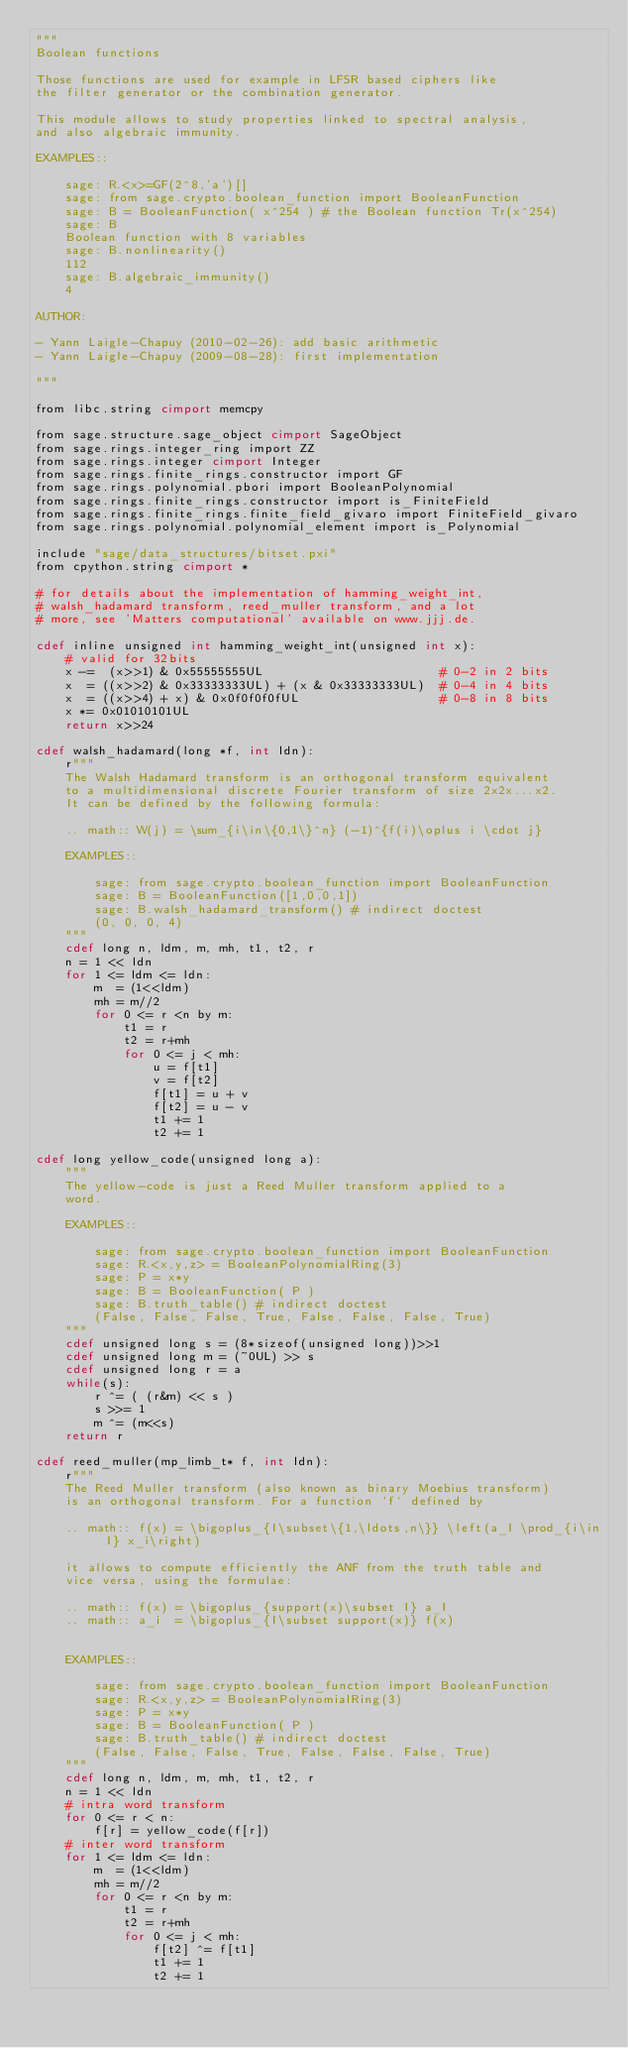<code> <loc_0><loc_0><loc_500><loc_500><_Cython_>"""
Boolean functions

Those functions are used for example in LFSR based ciphers like
the filter generator or the combination generator.

This module allows to study properties linked to spectral analysis,
and also algebraic immunity.

EXAMPLES::

    sage: R.<x>=GF(2^8,'a')[]
    sage: from sage.crypto.boolean_function import BooleanFunction
    sage: B = BooleanFunction( x^254 ) # the Boolean function Tr(x^254)
    sage: B
    Boolean function with 8 variables
    sage: B.nonlinearity()
    112
    sage: B.algebraic_immunity()
    4

AUTHOR:

- Yann Laigle-Chapuy (2010-02-26): add basic arithmetic
- Yann Laigle-Chapuy (2009-08-28): first implementation

"""

from libc.string cimport memcpy

from sage.structure.sage_object cimport SageObject
from sage.rings.integer_ring import ZZ
from sage.rings.integer cimport Integer
from sage.rings.finite_rings.constructor import GF
from sage.rings.polynomial.pbori import BooleanPolynomial
from sage.rings.finite_rings.constructor import is_FiniteField
from sage.rings.finite_rings.finite_field_givaro import FiniteField_givaro
from sage.rings.polynomial.polynomial_element import is_Polynomial

include "sage/data_structures/bitset.pxi"
from cpython.string cimport *

# for details about the implementation of hamming_weight_int,
# walsh_hadamard transform, reed_muller transform, and a lot
# more, see 'Matters computational' available on www.jjj.de.

cdef inline unsigned int hamming_weight_int(unsigned int x):
    # valid for 32bits
    x -=  (x>>1) & 0x55555555UL                        # 0-2 in 2 bits
    x  = ((x>>2) & 0x33333333UL) + (x & 0x33333333UL)  # 0-4 in 4 bits
    x  = ((x>>4) + x) & 0x0f0f0f0fUL                   # 0-8 in 8 bits
    x *= 0x01010101UL
    return x>>24

cdef walsh_hadamard(long *f, int ldn):
    r"""
    The Walsh Hadamard transform is an orthogonal transform equivalent
    to a multidimensional discrete Fourier transform of size 2x2x...x2.
    It can be defined by the following formula:

    .. math:: W(j) = \sum_{i\in\{0,1\}^n} (-1)^{f(i)\oplus i \cdot j}

    EXAMPLES::

        sage: from sage.crypto.boolean_function import BooleanFunction
        sage: B = BooleanFunction([1,0,0,1])
        sage: B.walsh_hadamard_transform() # indirect doctest
        (0, 0, 0, 4)
    """
    cdef long n, ldm, m, mh, t1, t2, r
    n = 1 << ldn
    for 1 <= ldm <= ldn:
        m  = (1<<ldm)
        mh = m//2
        for 0 <= r <n by m:
            t1 = r
            t2 = r+mh
            for 0 <= j < mh:
                u = f[t1]
                v = f[t2]
                f[t1] = u + v
                f[t2] = u - v
                t1 += 1
                t2 += 1

cdef long yellow_code(unsigned long a):
    """
    The yellow-code is just a Reed Muller transform applied to a
    word.

    EXAMPLES::

        sage: from sage.crypto.boolean_function import BooleanFunction
        sage: R.<x,y,z> = BooleanPolynomialRing(3)
        sage: P = x*y
        sage: B = BooleanFunction( P )
        sage: B.truth_table() # indirect doctest
        (False, False, False, True, False, False, False, True)
    """
    cdef unsigned long s = (8*sizeof(unsigned long))>>1
    cdef unsigned long m = (~0UL) >> s
    cdef unsigned long r = a
    while(s):
        r ^= ( (r&m) << s )
        s >>= 1
        m ^= (m<<s)
    return r

cdef reed_muller(mp_limb_t* f, int ldn):
    r"""
    The Reed Muller transform (also known as binary Moebius transform)
    is an orthogonal transform. For a function `f` defined by

    .. math:: f(x) = \bigoplus_{I\subset\{1,\ldots,n\}} \left(a_I \prod_{i\in I} x_i\right)

    it allows to compute efficiently the ANF from the truth table and
    vice versa, using the formulae:

    .. math:: f(x) = \bigoplus_{support(x)\subset I} a_I
    .. math:: a_i  = \bigoplus_{I\subset support(x)} f(x)


    EXAMPLES::

        sage: from sage.crypto.boolean_function import BooleanFunction
        sage: R.<x,y,z> = BooleanPolynomialRing(3)
        sage: P = x*y
        sage: B = BooleanFunction( P )
        sage: B.truth_table() # indirect doctest
        (False, False, False, True, False, False, False, True)
    """
    cdef long n, ldm, m, mh, t1, t2, r
    n = 1 << ldn
    # intra word transform
    for 0 <= r < n:
        f[r] = yellow_code(f[r])
    # inter word transform
    for 1 <= ldm <= ldn:
        m  = (1<<ldm)
        mh = m//2
        for 0 <= r <n by m:
            t1 = r
            t2 = r+mh
            for 0 <= j < mh:
                f[t2] ^= f[t1]
                t1 += 1
                t2 += 1
</code> 